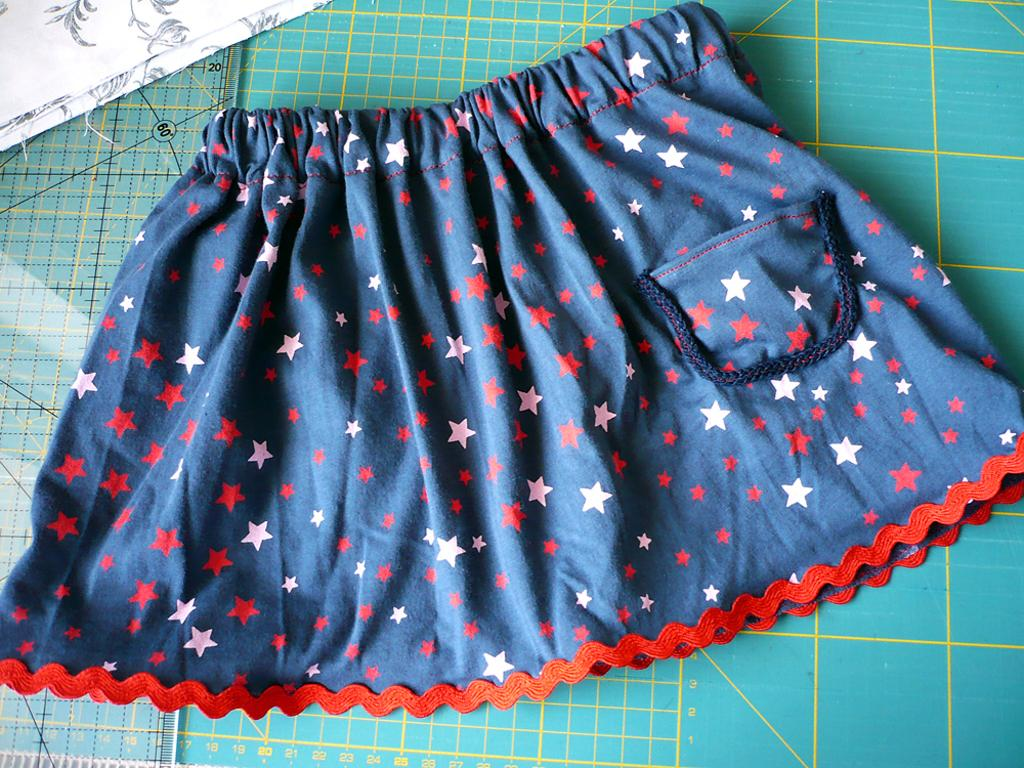What is hanging on the wall in the image? There is a skirt on the wall. What type of clothing is depicted in the image? The image features a skirt. Where is the skirt located in the image? The skirt is hanging on the wall. What type of brake system is depicted in the image? There is no brake system present in the image; it features a skirt hanging on the wall. What religious symbol can be seen in the image? There is no religious symbol present in the image; it features a skirt hanging on the wall. 